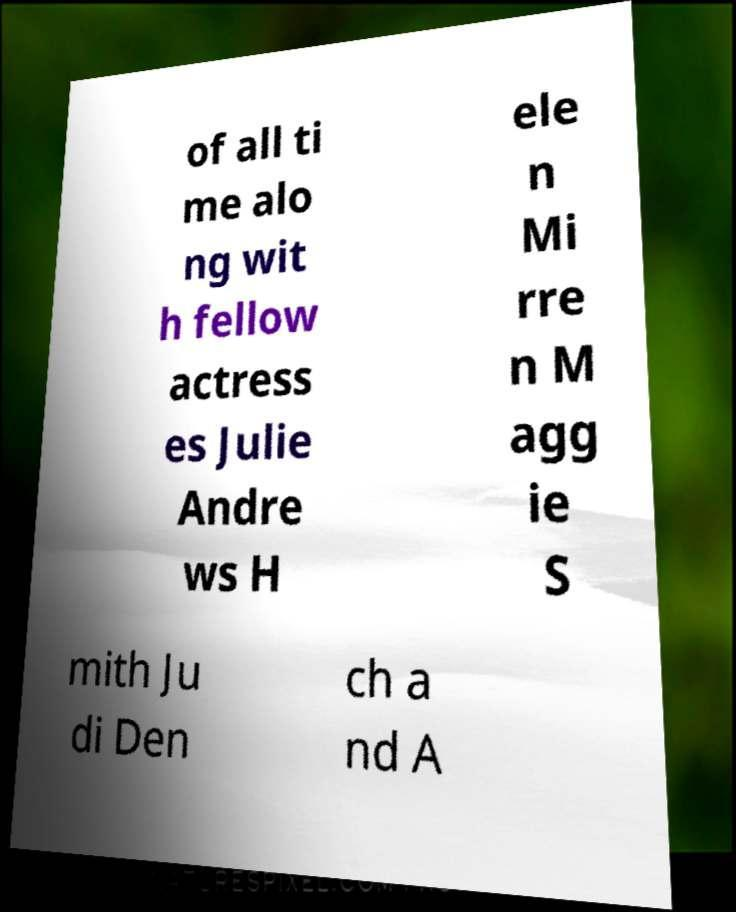There's text embedded in this image that I need extracted. Can you transcribe it verbatim? of all ti me alo ng wit h fellow actress es Julie Andre ws H ele n Mi rre n M agg ie S mith Ju di Den ch a nd A 